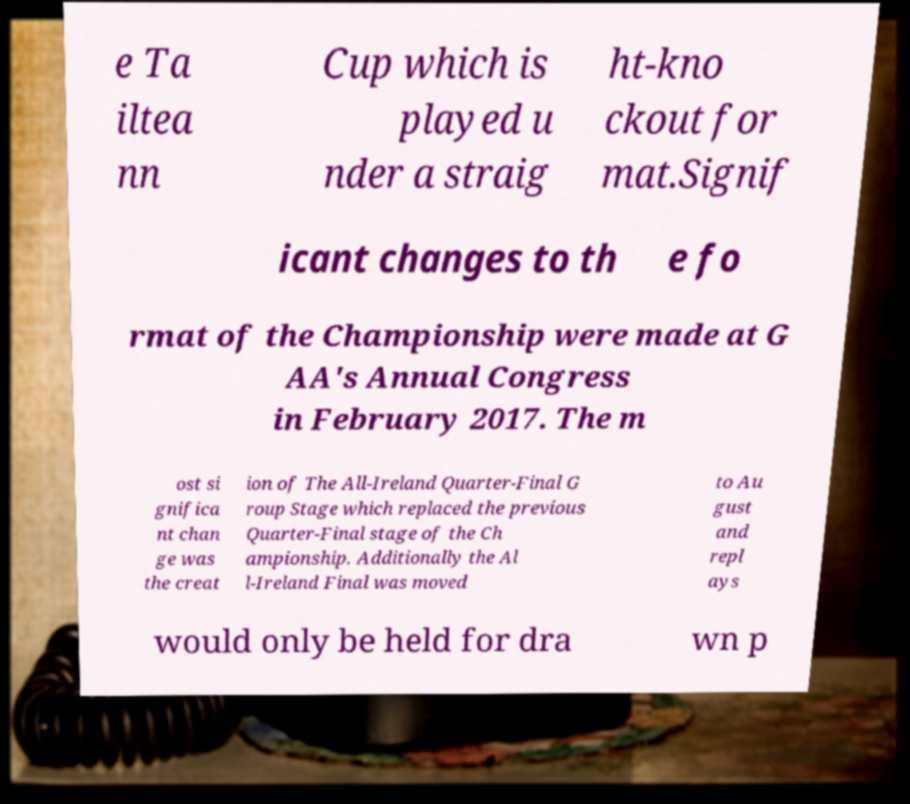Could you assist in decoding the text presented in this image and type it out clearly? e Ta iltea nn Cup which is played u nder a straig ht-kno ckout for mat.Signif icant changes to th e fo rmat of the Championship were made at G AA's Annual Congress in February 2017. The m ost si gnifica nt chan ge was the creat ion of The All-Ireland Quarter-Final G roup Stage which replaced the previous Quarter-Final stage of the Ch ampionship. Additionally the Al l-Ireland Final was moved to Au gust and repl ays would only be held for dra wn p 